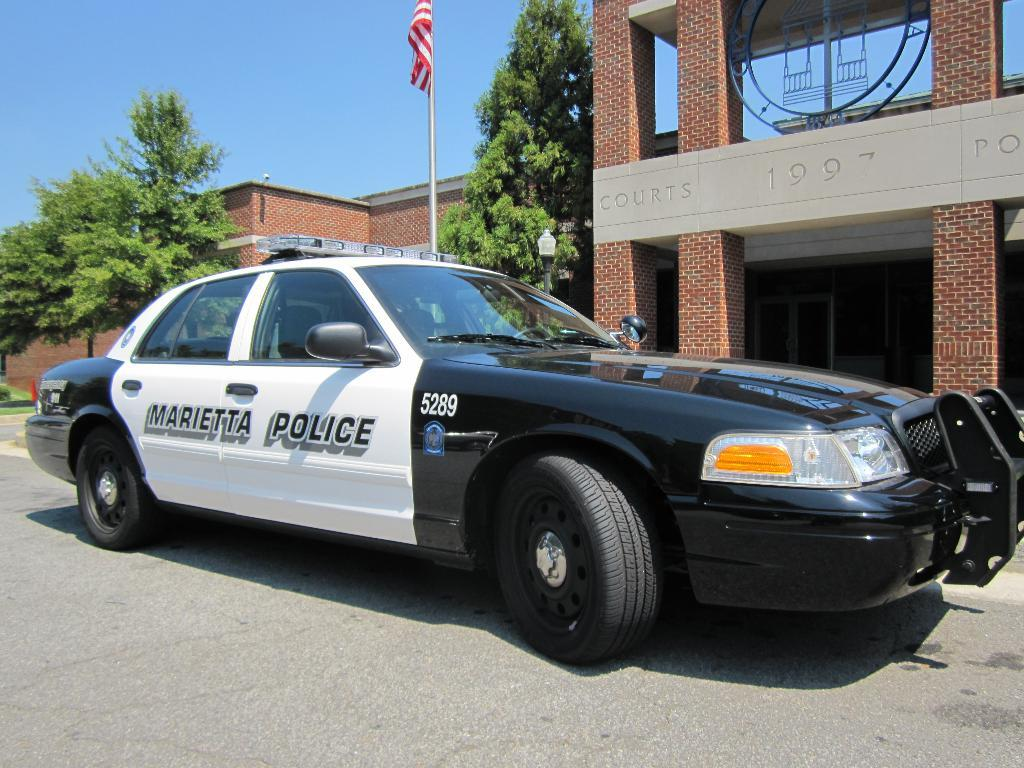<image>
Summarize the visual content of the image. A white and black parked Marietta Police car. 